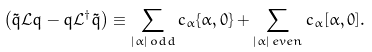<formula> <loc_0><loc_0><loc_500><loc_500>\left ( \tilde { q } \mathcal { L } q - q \mathcal { L } ^ { \dagger } \tilde { q } \right ) \equiv \sum _ { | \alpha | \, o d d } c _ { \alpha } \{ \alpha , 0 \} + \sum _ { | \alpha | \, e v e n } c _ { \alpha } [ \alpha , 0 ] .</formula> 